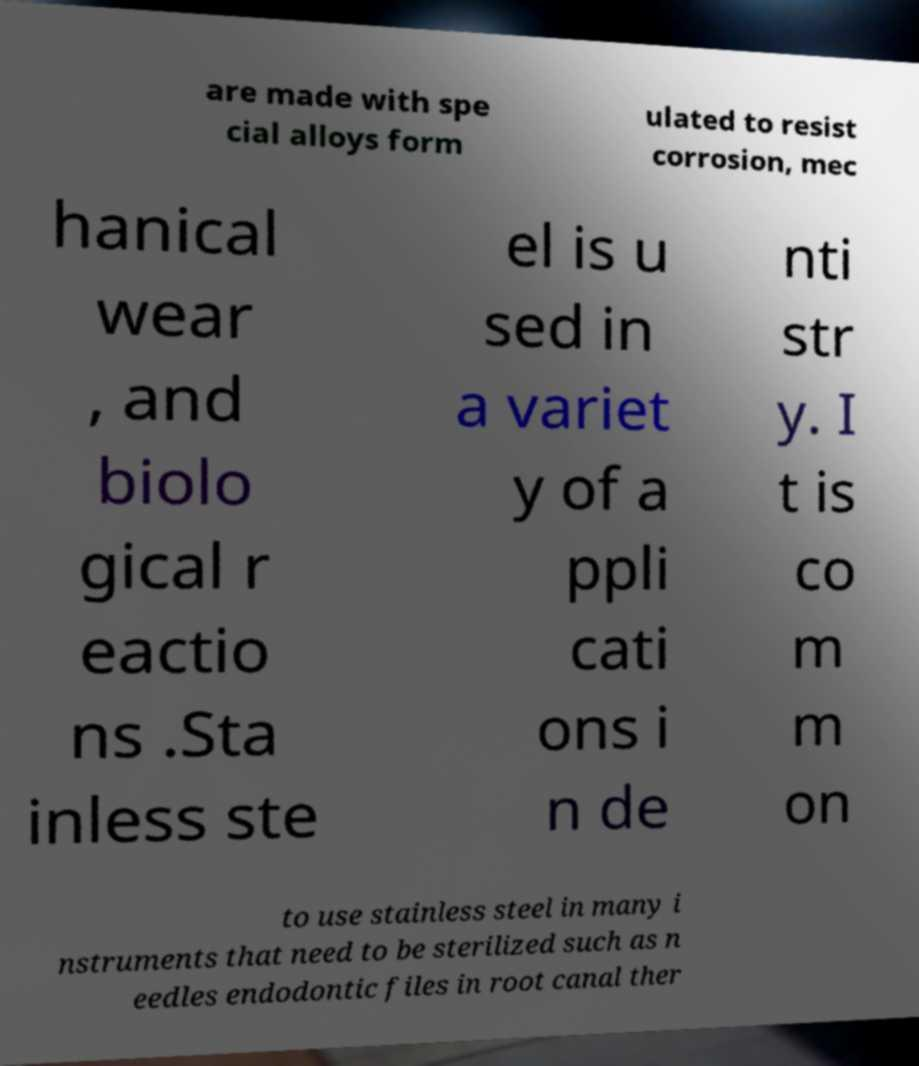I need the written content from this picture converted into text. Can you do that? are made with spe cial alloys form ulated to resist corrosion, mec hanical wear , and biolo gical r eactio ns .Sta inless ste el is u sed in a variet y of a ppli cati ons i n de nti str y. I t is co m m on to use stainless steel in many i nstruments that need to be sterilized such as n eedles endodontic files in root canal ther 